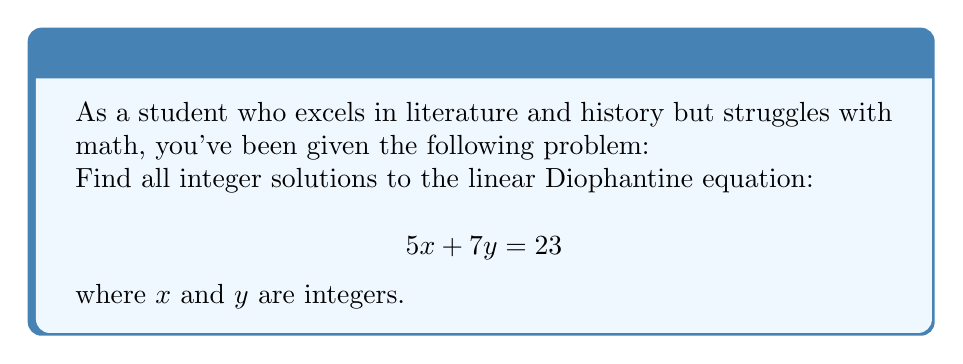Give your solution to this math problem. Let's approach this step-by-step:

1) First, we need to check if a solution exists. A linear Diophantine equation $ax + by = c$ has a solution if and only if the greatest common divisor (GCD) of $a$ and $b$ divides $c$.

   $GCD(5,7) = 1$ (since 5 and 7 are prime)
   $1$ divides $23$, so a solution exists.

2) We can use the extended Euclidean algorithm to find a particular solution. Let's apply it:

   $7 = 1 \cdot 5 + 2$
   $5 = 2 \cdot 2 + 1$
   $2 = 2 \cdot 1 + 0$

   Working backwards:
   $1 = 5 - 2 \cdot 2$
   $1 = 5 - 2(7 - 1 \cdot 5) = 3 \cdot 5 - 2 \cdot 7$

3) Multiply both sides by 23:
   $23 = 69 \cdot 5 - 46 \cdot 7$

4) Therefore, a particular solution is $x_0 = 69$, $y_0 = -46$

5) The general solution is given by:
   $x = x_0 - bt = 69 - 7t$
   $y = y_0 + at = -46 + 5t$
   where $t$ is any integer.

6) We can simplify this to:
   $x = 69 - 7t$
   $y = -46 + 5t$
   for any integer $t$.
Answer: The general solution to the Diophantine equation $5x + 7y = 23$ is:

$x = 69 - 7t$
$y = -46 + 5t$

where $t$ is any integer. 